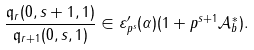Convert formula to latex. <formula><loc_0><loc_0><loc_500><loc_500>\frac { \mathfrak { q } _ { r } ( 0 , s + 1 , 1 ) } { \mathfrak { q } _ { r + 1 } ( 0 , s , 1 ) } \in \varepsilon _ { p ^ { s } } ^ { \prime } ( \alpha ) ( 1 + p ^ { s + 1 } \mathcal { A } _ { b } ^ { \ast } ) .</formula> 